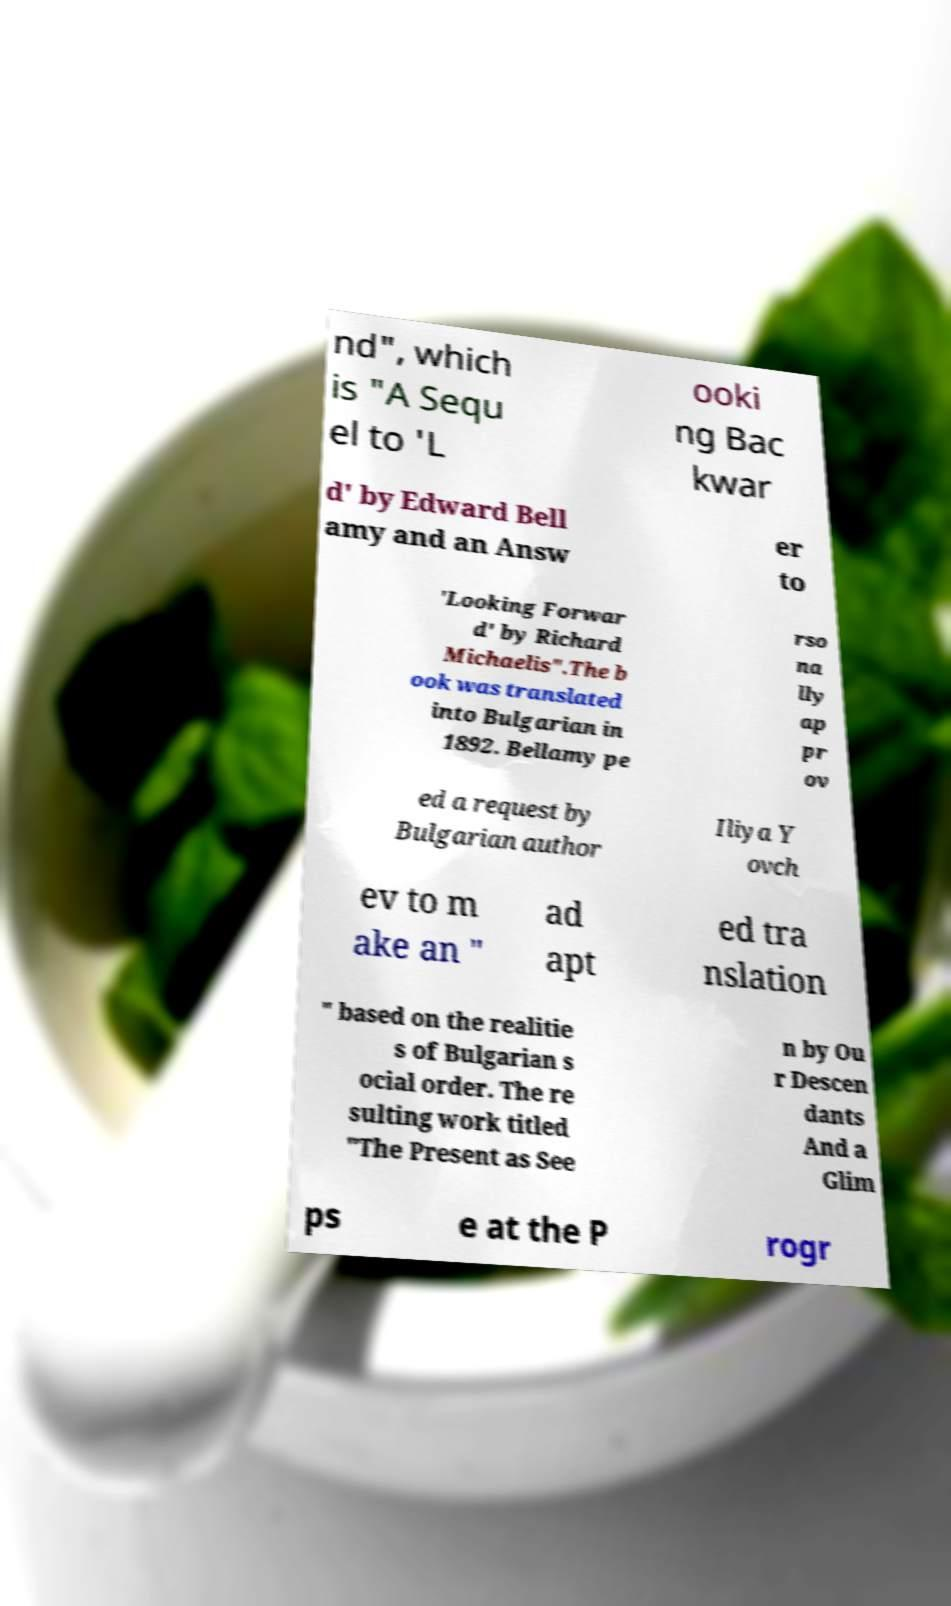Can you accurately transcribe the text from the provided image for me? nd", which is "A Sequ el to 'L ooki ng Bac kwar d' by Edward Bell amy and an Answ er to 'Looking Forwar d' by Richard Michaelis".The b ook was translated into Bulgarian in 1892. Bellamy pe rso na lly ap pr ov ed a request by Bulgarian author Iliya Y ovch ev to m ake an " ad apt ed tra nslation " based on the realitie s of Bulgarian s ocial order. The re sulting work titled "The Present as See n by Ou r Descen dants And a Glim ps e at the P rogr 